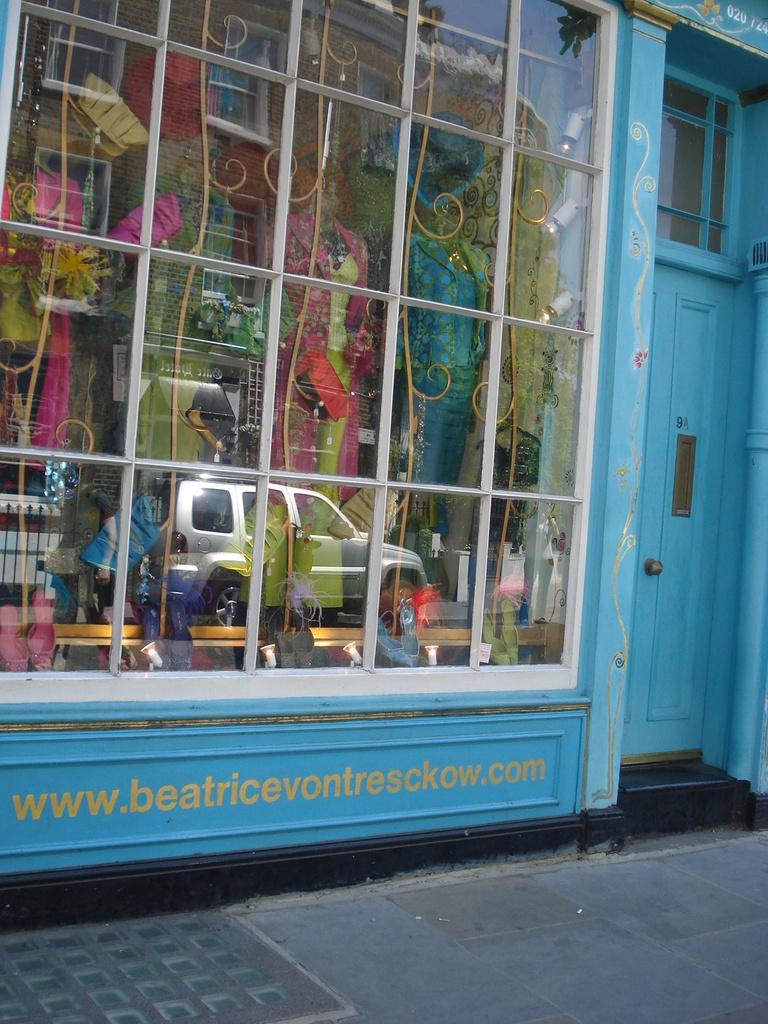What type of establishment is depicted in the image? There is a shop in the image. What can be found inside the shop? The shop contains clothes. Is there a grassy field visible behind the shop? There is no mention of a grassy field or any outdoor elements in the provided facts, so we cannot determine if one is present. 